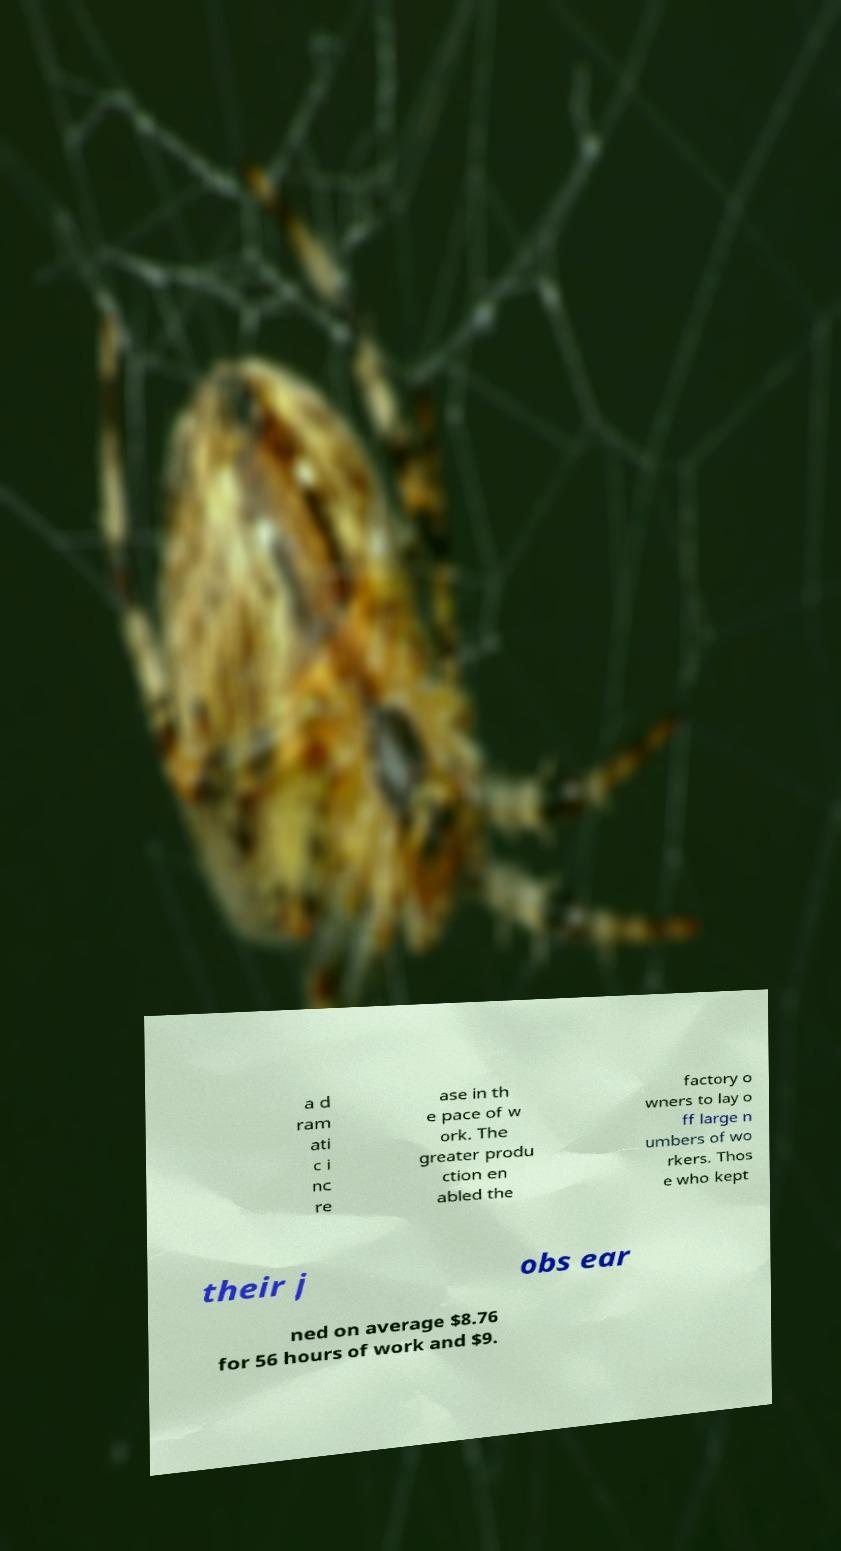What messages or text are displayed in this image? I need them in a readable, typed format. a d ram ati c i nc re ase in th e pace of w ork. The greater produ ction en abled the factory o wners to lay o ff large n umbers of wo rkers. Thos e who kept their j obs ear ned on average $8.76 for 56 hours of work and $9. 